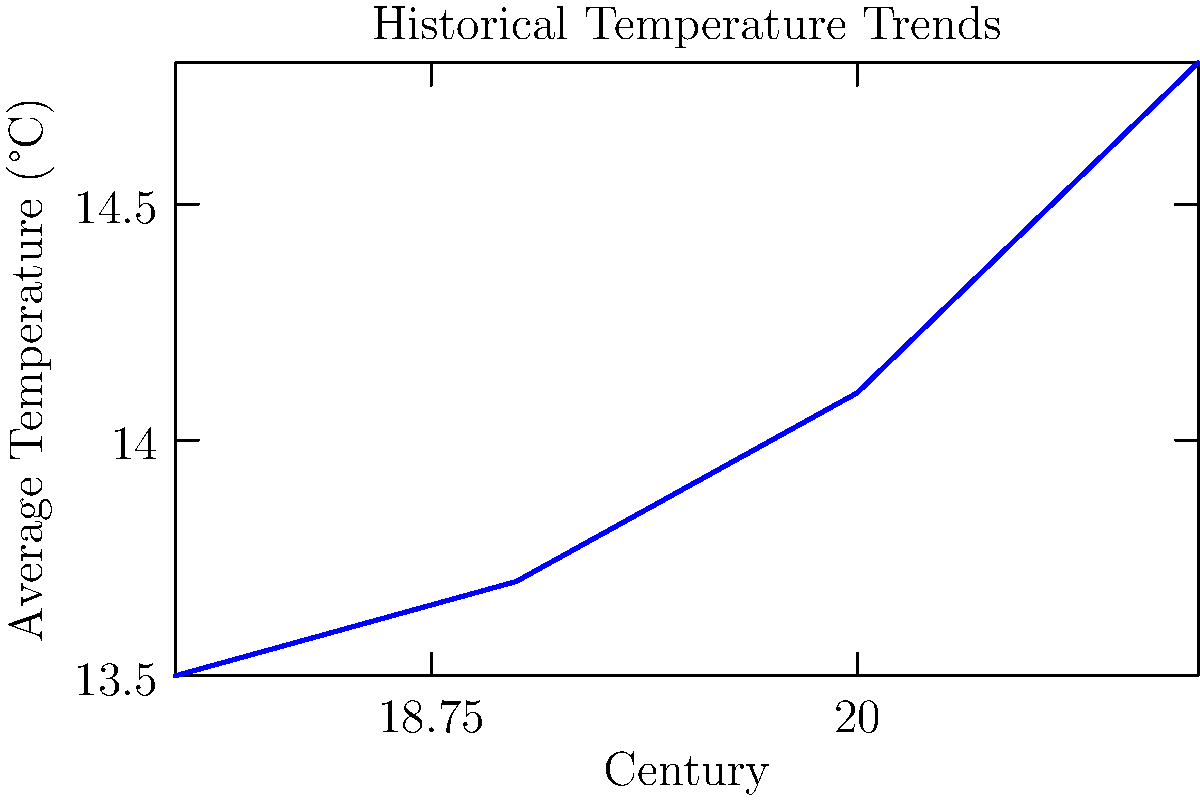Based on the line graph showing historical temperature trends across different centuries, what is the approximate rate of temperature increase per century between the 18th and 21st centuries? To calculate the rate of temperature increase per century:

1. Find total temperature change:
   21st century temp (14.8°C) - 18th century temp (13.5°C) = 1.3°C

2. Find total time span:
   21st century - 18th century = 3 centuries

3. Calculate rate of change:
   $$\text{Rate} = \frac{\text{Change in temperature}}{\text{Change in time}} = \frac{1.3\text{°C}}{3\text{ centuries}} \approx 0.43\text{°C/century}$$

4. Round to two decimal places: 0.43°C/century

This rate represents the average increase in temperature per century over the given time period.
Answer: 0.43°C/century 